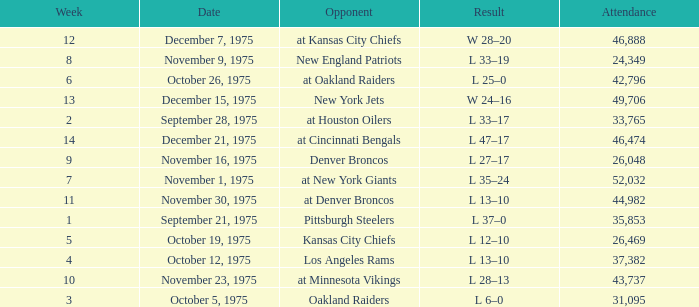What is the lowest Week when the result was l 13–10, November 30, 1975, with more than 44,982 people in attendance? None. 